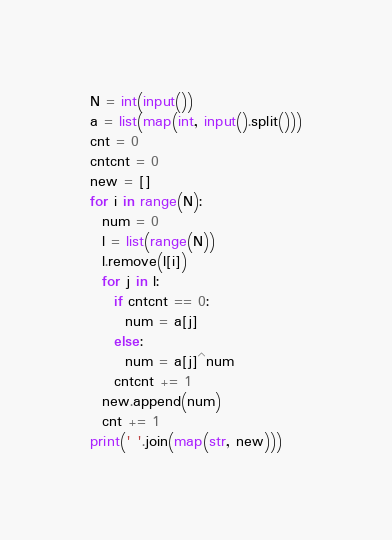<code> <loc_0><loc_0><loc_500><loc_500><_Python_>N = int(input())
a = list(map(int, input().split()))
cnt = 0
cntcnt = 0
new = []
for i in range(N):
  num = 0
  l = list(range(N))
  l.remove(l[i])
  for j in l:
    if cntcnt == 0:
      num = a[j]
    else:
      num = a[j]^num
    cntcnt += 1
  new.append(num)
  cnt += 1
print(' '.join(map(str, new)))</code> 